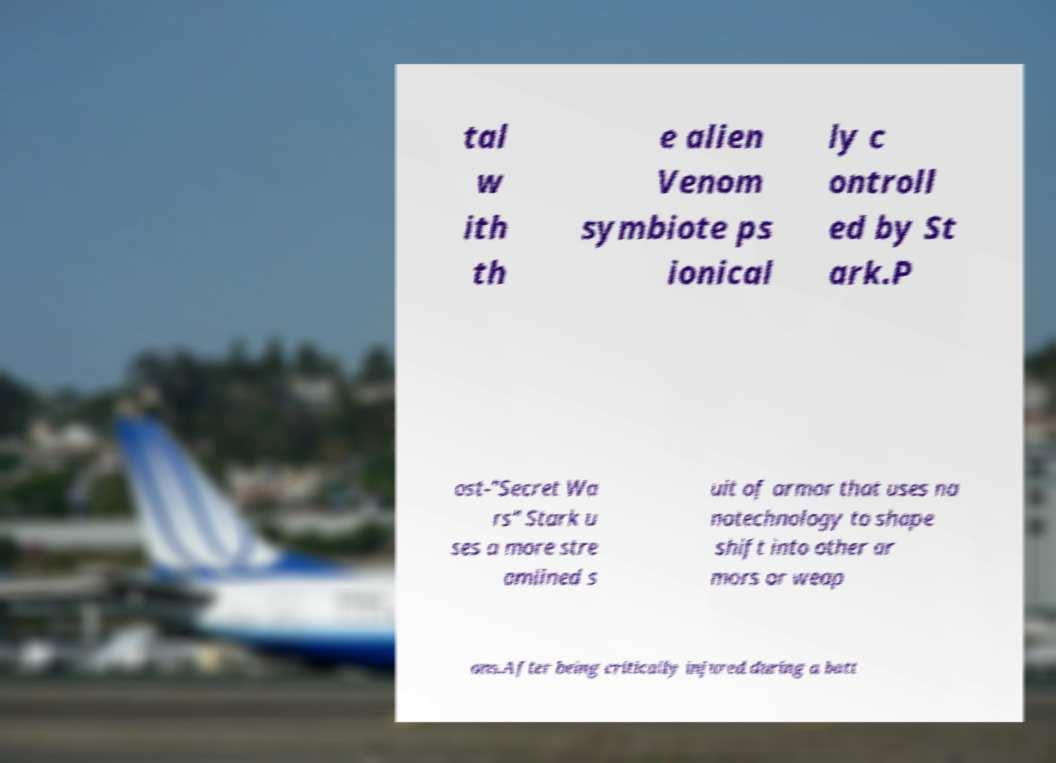There's text embedded in this image that I need extracted. Can you transcribe it verbatim? tal w ith th e alien Venom symbiote ps ionical ly c ontroll ed by St ark.P ost-"Secret Wa rs" Stark u ses a more stre amlined s uit of armor that uses na notechnology to shape shift into other ar mors or weap ons.After being critically injured during a batt 